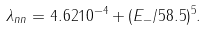<formula> <loc_0><loc_0><loc_500><loc_500>\lambda _ { n n } = 4 . 6 2 1 0 ^ { - 4 } + ( E _ { - } / 5 8 . 5 ) ^ { 5 } .</formula> 